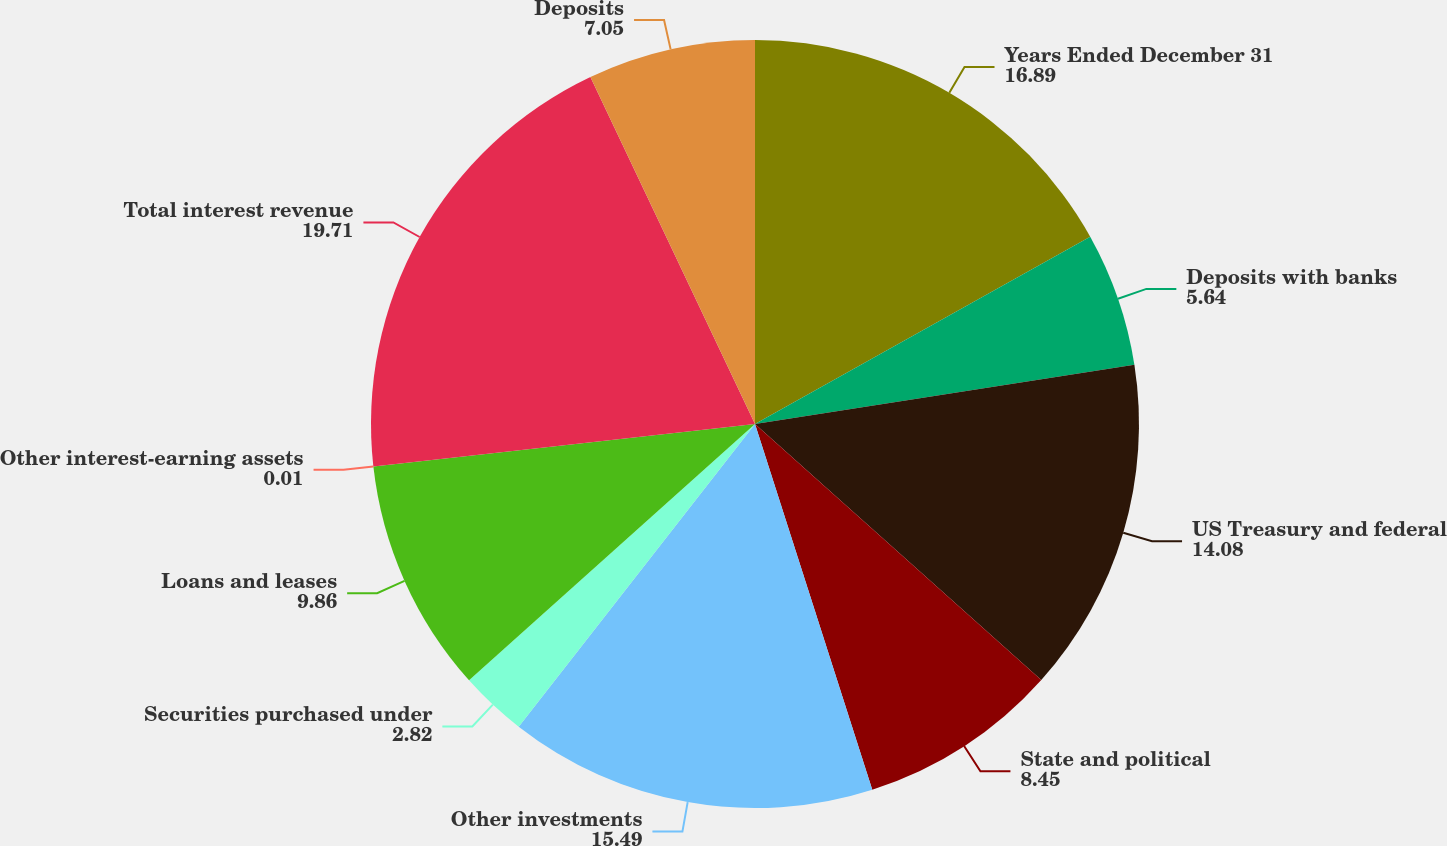<chart> <loc_0><loc_0><loc_500><loc_500><pie_chart><fcel>Years Ended December 31<fcel>Deposits with banks<fcel>US Treasury and federal<fcel>State and political<fcel>Other investments<fcel>Securities purchased under<fcel>Loans and leases<fcel>Other interest-earning assets<fcel>Total interest revenue<fcel>Deposits<nl><fcel>16.89%<fcel>5.64%<fcel>14.08%<fcel>8.45%<fcel>15.49%<fcel>2.82%<fcel>9.86%<fcel>0.01%<fcel>19.71%<fcel>7.05%<nl></chart> 